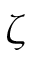Convert formula to latex. <formula><loc_0><loc_0><loc_500><loc_500>\zeta</formula> 